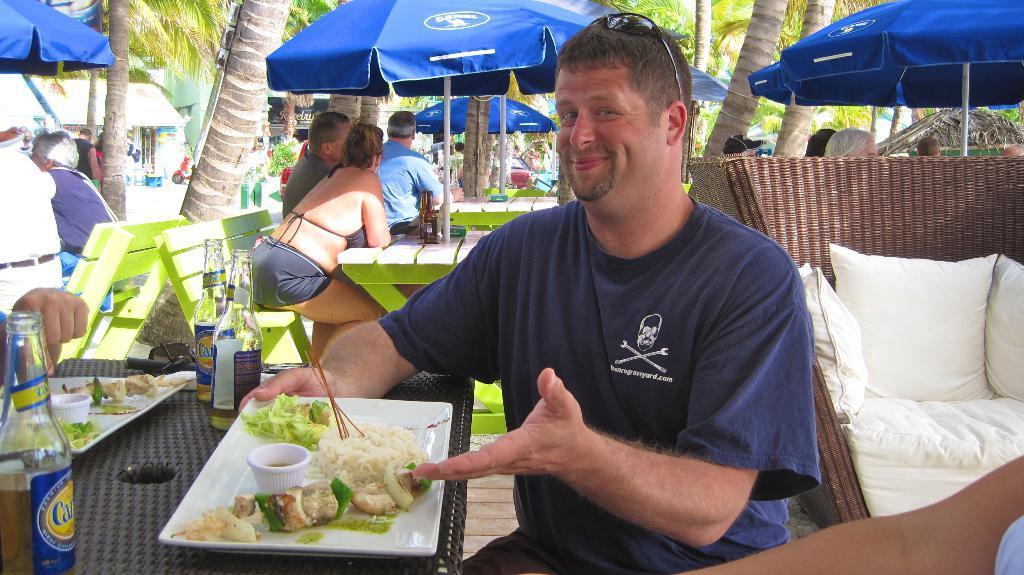In one or two sentences, can you explain what this image depicts? There is one man sitting and holding a plate as we can see at the bottom of this image. We can see trees, umbrellas and other people in the background. We can see pillows on the left side of this image. There are bottles and food items are kept on a table as we can see in the bottom left corner of this image. 